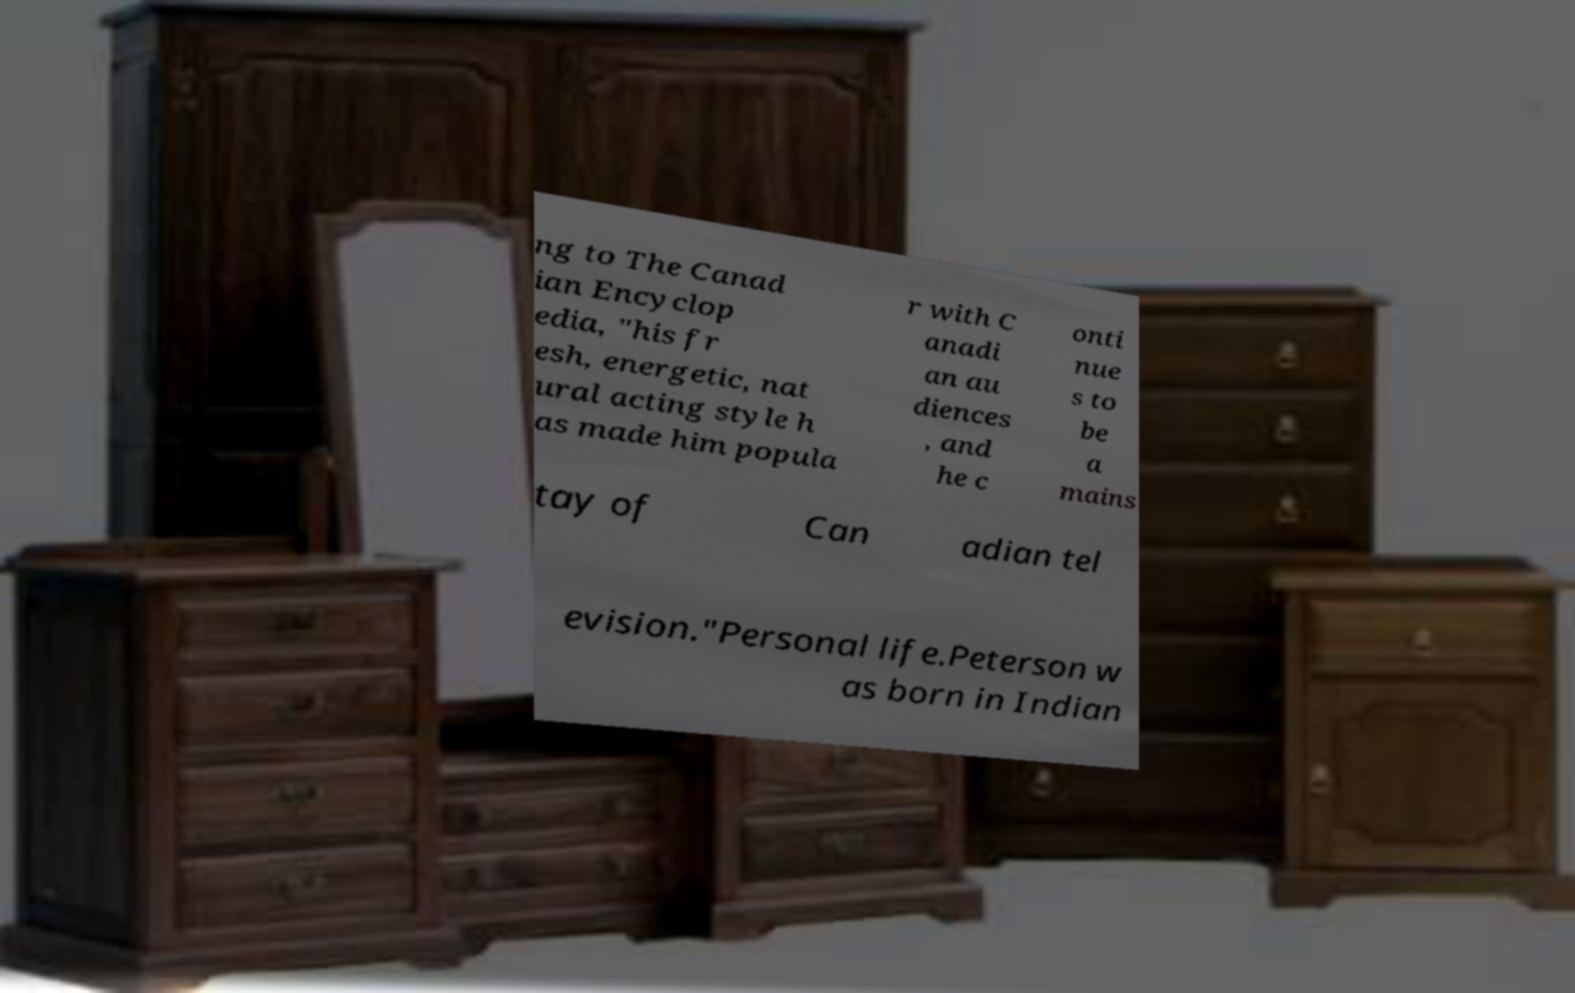What messages or text are displayed in this image? I need them in a readable, typed format. ng to The Canad ian Encyclop edia, "his fr esh, energetic, nat ural acting style h as made him popula r with C anadi an au diences , and he c onti nue s to be a mains tay of Can adian tel evision."Personal life.Peterson w as born in Indian 